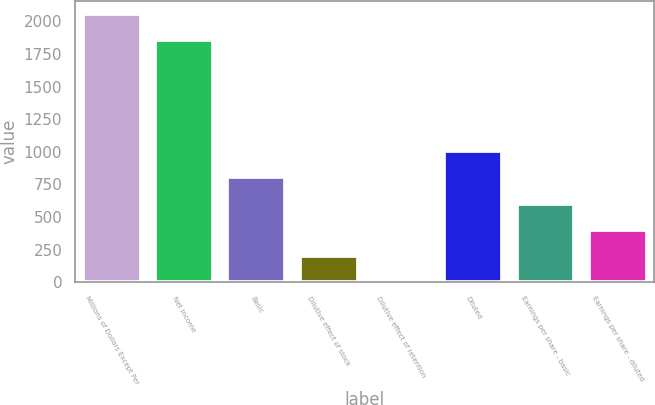Convert chart. <chart><loc_0><loc_0><loc_500><loc_500><bar_chart><fcel>Millions of Dollars Except Per<fcel>Net income<fcel>Basic<fcel>Dilutive effect of stock<fcel>Dilutive effect of retention<fcel>Diluted<fcel>Earnings per share - basic<fcel>Earnings per share - diluted<nl><fcel>2055.66<fcel>1855<fcel>803.04<fcel>201.06<fcel>0.4<fcel>1003.7<fcel>602.38<fcel>401.72<nl></chart> 